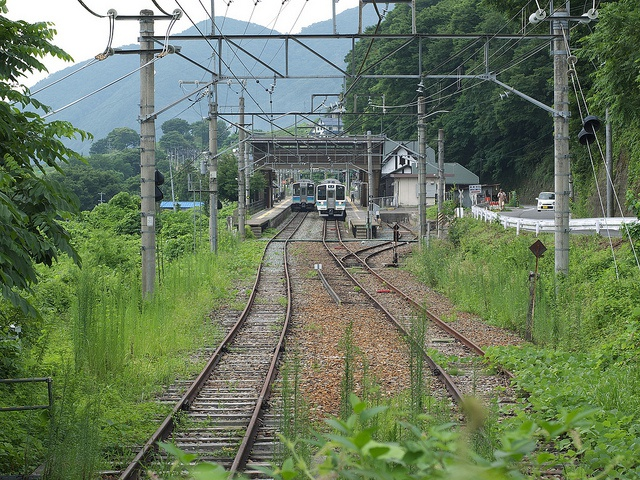Describe the objects in this image and their specific colors. I can see train in lightgray, black, darkgray, and gray tones, train in lightgray, gray, black, darkgray, and purple tones, car in lightgray, darkgray, gray, and black tones, train in lightgray, black, gray, darkgray, and teal tones, and people in lightgray, darkgray, and gray tones in this image. 